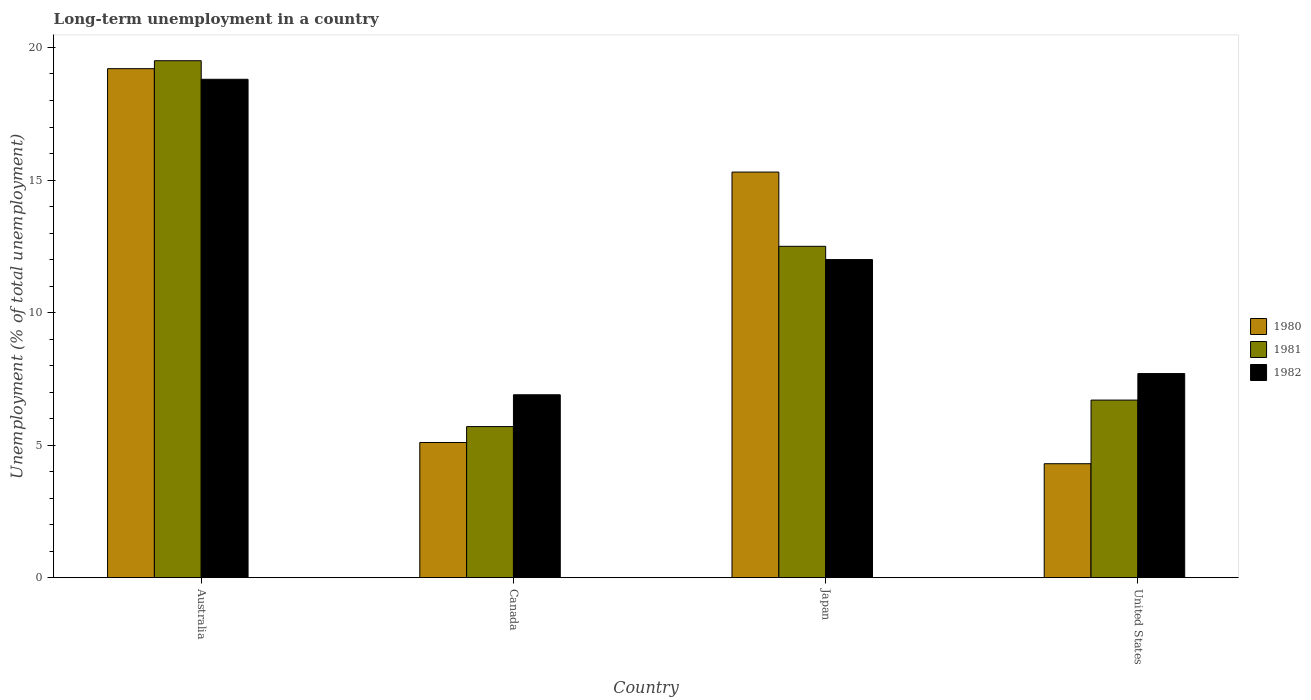How many different coloured bars are there?
Offer a very short reply. 3. What is the label of the 4th group of bars from the left?
Your response must be concise. United States. In how many cases, is the number of bars for a given country not equal to the number of legend labels?
Offer a terse response. 0. What is the percentage of long-term unemployed population in 1982 in Australia?
Keep it short and to the point. 18.8. Across all countries, what is the maximum percentage of long-term unemployed population in 1980?
Make the answer very short. 19.2. Across all countries, what is the minimum percentage of long-term unemployed population in 1981?
Provide a succinct answer. 5.7. In which country was the percentage of long-term unemployed population in 1982 maximum?
Offer a very short reply. Australia. In which country was the percentage of long-term unemployed population in 1981 minimum?
Keep it short and to the point. Canada. What is the total percentage of long-term unemployed population in 1981 in the graph?
Keep it short and to the point. 44.4. What is the difference between the percentage of long-term unemployed population in 1981 in Canada and that in United States?
Keep it short and to the point. -1. What is the difference between the percentage of long-term unemployed population in 1982 in Australia and the percentage of long-term unemployed population in 1981 in Canada?
Keep it short and to the point. 13.1. What is the average percentage of long-term unemployed population in 1981 per country?
Provide a short and direct response. 11.1. What is the difference between the percentage of long-term unemployed population of/in 1982 and percentage of long-term unemployed population of/in 1981 in Australia?
Offer a terse response. -0.7. What is the ratio of the percentage of long-term unemployed population in 1980 in Canada to that in Japan?
Provide a short and direct response. 0.33. Is the percentage of long-term unemployed population in 1981 in Australia less than that in Japan?
Your response must be concise. No. What is the difference between the highest and the lowest percentage of long-term unemployed population in 1980?
Offer a terse response. 14.9. In how many countries, is the percentage of long-term unemployed population in 1980 greater than the average percentage of long-term unemployed population in 1980 taken over all countries?
Ensure brevity in your answer.  2. What does the 2nd bar from the left in Australia represents?
Ensure brevity in your answer.  1981. What does the 2nd bar from the right in Japan represents?
Offer a very short reply. 1981. Are all the bars in the graph horizontal?
Keep it short and to the point. No. Are the values on the major ticks of Y-axis written in scientific E-notation?
Provide a short and direct response. No. Does the graph contain any zero values?
Keep it short and to the point. No. Does the graph contain grids?
Provide a succinct answer. No. How many legend labels are there?
Make the answer very short. 3. What is the title of the graph?
Give a very brief answer. Long-term unemployment in a country. What is the label or title of the X-axis?
Offer a very short reply. Country. What is the label or title of the Y-axis?
Give a very brief answer. Unemployment (% of total unemployment). What is the Unemployment (% of total unemployment) of 1980 in Australia?
Provide a short and direct response. 19.2. What is the Unemployment (% of total unemployment) in 1982 in Australia?
Your answer should be very brief. 18.8. What is the Unemployment (% of total unemployment) in 1980 in Canada?
Your answer should be very brief. 5.1. What is the Unemployment (% of total unemployment) of 1981 in Canada?
Your answer should be very brief. 5.7. What is the Unemployment (% of total unemployment) in 1982 in Canada?
Keep it short and to the point. 6.9. What is the Unemployment (% of total unemployment) in 1980 in Japan?
Make the answer very short. 15.3. What is the Unemployment (% of total unemployment) in 1980 in United States?
Your answer should be compact. 4.3. What is the Unemployment (% of total unemployment) in 1981 in United States?
Offer a very short reply. 6.7. What is the Unemployment (% of total unemployment) in 1982 in United States?
Your response must be concise. 7.7. Across all countries, what is the maximum Unemployment (% of total unemployment) of 1980?
Provide a short and direct response. 19.2. Across all countries, what is the maximum Unemployment (% of total unemployment) in 1981?
Keep it short and to the point. 19.5. Across all countries, what is the maximum Unemployment (% of total unemployment) of 1982?
Ensure brevity in your answer.  18.8. Across all countries, what is the minimum Unemployment (% of total unemployment) of 1980?
Your answer should be compact. 4.3. Across all countries, what is the minimum Unemployment (% of total unemployment) in 1981?
Offer a very short reply. 5.7. Across all countries, what is the minimum Unemployment (% of total unemployment) in 1982?
Provide a short and direct response. 6.9. What is the total Unemployment (% of total unemployment) of 1980 in the graph?
Make the answer very short. 43.9. What is the total Unemployment (% of total unemployment) of 1981 in the graph?
Your response must be concise. 44.4. What is the total Unemployment (% of total unemployment) in 1982 in the graph?
Provide a succinct answer. 45.4. What is the difference between the Unemployment (% of total unemployment) in 1982 in Australia and that in Canada?
Your response must be concise. 11.9. What is the difference between the Unemployment (% of total unemployment) of 1982 in Australia and that in United States?
Your answer should be very brief. 11.1. What is the difference between the Unemployment (% of total unemployment) of 1980 in Canada and that in Japan?
Offer a very short reply. -10.2. What is the difference between the Unemployment (% of total unemployment) of 1981 in Canada and that in Japan?
Offer a terse response. -6.8. What is the difference between the Unemployment (% of total unemployment) of 1982 in Canada and that in Japan?
Make the answer very short. -5.1. What is the difference between the Unemployment (% of total unemployment) in 1980 in Canada and that in United States?
Ensure brevity in your answer.  0.8. What is the difference between the Unemployment (% of total unemployment) of 1982 in Canada and that in United States?
Your answer should be compact. -0.8. What is the difference between the Unemployment (% of total unemployment) in 1980 in Japan and that in United States?
Your response must be concise. 11. What is the difference between the Unemployment (% of total unemployment) in 1980 in Australia and the Unemployment (% of total unemployment) in 1981 in Japan?
Provide a short and direct response. 6.7. What is the difference between the Unemployment (% of total unemployment) in 1980 in Australia and the Unemployment (% of total unemployment) in 1982 in Japan?
Provide a succinct answer. 7.2. What is the difference between the Unemployment (% of total unemployment) in 1980 in Australia and the Unemployment (% of total unemployment) in 1981 in United States?
Give a very brief answer. 12.5. What is the difference between the Unemployment (% of total unemployment) of 1981 in Australia and the Unemployment (% of total unemployment) of 1982 in United States?
Offer a terse response. 11.8. What is the difference between the Unemployment (% of total unemployment) of 1980 in Canada and the Unemployment (% of total unemployment) of 1981 in Japan?
Keep it short and to the point. -7.4. What is the difference between the Unemployment (% of total unemployment) in 1981 in Canada and the Unemployment (% of total unemployment) in 1982 in United States?
Make the answer very short. -2. What is the difference between the Unemployment (% of total unemployment) of 1980 in Japan and the Unemployment (% of total unemployment) of 1981 in United States?
Your answer should be compact. 8.6. What is the difference between the Unemployment (% of total unemployment) of 1981 in Japan and the Unemployment (% of total unemployment) of 1982 in United States?
Give a very brief answer. 4.8. What is the average Unemployment (% of total unemployment) of 1980 per country?
Offer a very short reply. 10.97. What is the average Unemployment (% of total unemployment) in 1981 per country?
Offer a very short reply. 11.1. What is the average Unemployment (% of total unemployment) of 1982 per country?
Make the answer very short. 11.35. What is the difference between the Unemployment (% of total unemployment) of 1980 and Unemployment (% of total unemployment) of 1981 in Canada?
Offer a terse response. -0.6. What is the difference between the Unemployment (% of total unemployment) in 1980 and Unemployment (% of total unemployment) in 1981 in Japan?
Provide a succinct answer. 2.8. What is the difference between the Unemployment (% of total unemployment) in 1980 and Unemployment (% of total unemployment) in 1982 in Japan?
Make the answer very short. 3.3. What is the difference between the Unemployment (% of total unemployment) in 1981 and Unemployment (% of total unemployment) in 1982 in Japan?
Provide a short and direct response. 0.5. What is the difference between the Unemployment (% of total unemployment) in 1980 and Unemployment (% of total unemployment) in 1981 in United States?
Provide a short and direct response. -2.4. What is the difference between the Unemployment (% of total unemployment) in 1981 and Unemployment (% of total unemployment) in 1982 in United States?
Offer a very short reply. -1. What is the ratio of the Unemployment (% of total unemployment) in 1980 in Australia to that in Canada?
Provide a succinct answer. 3.76. What is the ratio of the Unemployment (% of total unemployment) of 1981 in Australia to that in Canada?
Your response must be concise. 3.42. What is the ratio of the Unemployment (% of total unemployment) of 1982 in Australia to that in Canada?
Your response must be concise. 2.72. What is the ratio of the Unemployment (% of total unemployment) of 1980 in Australia to that in Japan?
Your response must be concise. 1.25. What is the ratio of the Unemployment (% of total unemployment) of 1981 in Australia to that in Japan?
Offer a terse response. 1.56. What is the ratio of the Unemployment (% of total unemployment) of 1982 in Australia to that in Japan?
Provide a succinct answer. 1.57. What is the ratio of the Unemployment (% of total unemployment) of 1980 in Australia to that in United States?
Ensure brevity in your answer.  4.47. What is the ratio of the Unemployment (% of total unemployment) in 1981 in Australia to that in United States?
Offer a very short reply. 2.91. What is the ratio of the Unemployment (% of total unemployment) of 1982 in Australia to that in United States?
Your answer should be compact. 2.44. What is the ratio of the Unemployment (% of total unemployment) of 1980 in Canada to that in Japan?
Keep it short and to the point. 0.33. What is the ratio of the Unemployment (% of total unemployment) in 1981 in Canada to that in Japan?
Your answer should be very brief. 0.46. What is the ratio of the Unemployment (% of total unemployment) of 1982 in Canada to that in Japan?
Provide a succinct answer. 0.57. What is the ratio of the Unemployment (% of total unemployment) in 1980 in Canada to that in United States?
Your response must be concise. 1.19. What is the ratio of the Unemployment (% of total unemployment) of 1981 in Canada to that in United States?
Your answer should be very brief. 0.85. What is the ratio of the Unemployment (% of total unemployment) in 1982 in Canada to that in United States?
Provide a short and direct response. 0.9. What is the ratio of the Unemployment (% of total unemployment) in 1980 in Japan to that in United States?
Keep it short and to the point. 3.56. What is the ratio of the Unemployment (% of total unemployment) of 1981 in Japan to that in United States?
Offer a terse response. 1.87. What is the ratio of the Unemployment (% of total unemployment) in 1982 in Japan to that in United States?
Your response must be concise. 1.56. What is the difference between the highest and the second highest Unemployment (% of total unemployment) in 1980?
Give a very brief answer. 3.9. What is the difference between the highest and the second highest Unemployment (% of total unemployment) of 1981?
Provide a short and direct response. 7. What is the difference between the highest and the second highest Unemployment (% of total unemployment) of 1982?
Your answer should be compact. 6.8. What is the difference between the highest and the lowest Unemployment (% of total unemployment) of 1981?
Give a very brief answer. 13.8. 